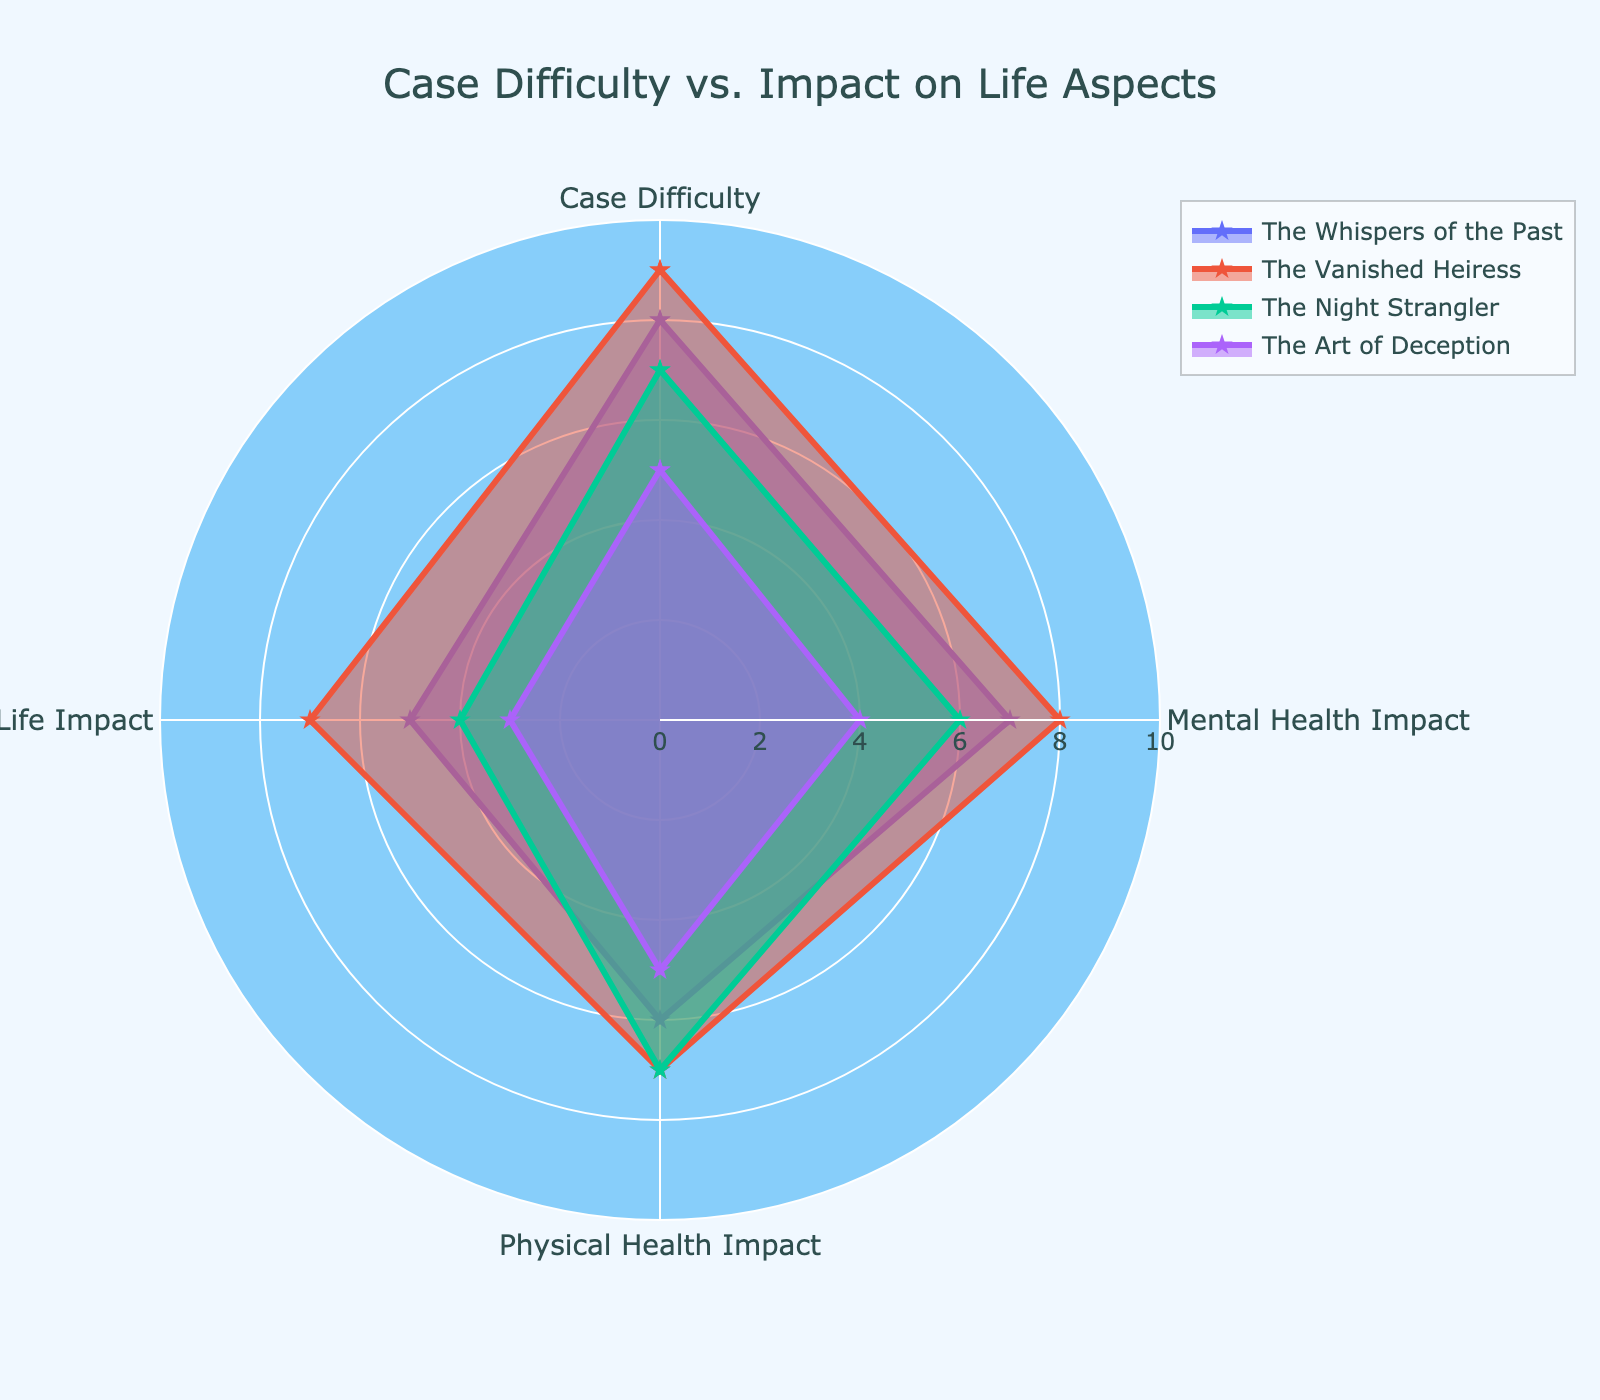What is the title of the radar chart? The title of the radar chart is located at the top of the chart and is clearly labeled.
Answer: Case Difficulty vs. Impact on Life Aspects How many cases are represented in the radar chart? By counting the unique lines or polygons in the radar chart's legend and each category, we can determine the number of cases represented.
Answer: Four Which case has the highest difficulty? Compare the "Case Difficulty" values for each case; the case with the highest value has the highest difficulty.
Answer: The Vanished Heiress Which case has the least impact on social life? Compare the "Social Life Impact" values for each case; the case with the lowest value indicates the least impact on social life.
Answer: The Art of Deception What are the three main categories displayed on the radar chart? The radar chart includes the categories along the axes; the primary three are "Mental Health Impact," "Physical Health Impact," and "Social Life Impact."
Answer: Mental Health Impact, Physical Health Impact, Social Life Impact By how much does the physical health impact of "The Vanished Heiress" surpass that of "The Art of Deception"? Subtract the "Physical Health Impact" value of "The Art of Deception" from that of "The Vanished Heiress."
Answer: 2 Which case shows the highest impact on mental health? Compare the "Mental Health Impact" values across cases; the highest value reveals the case with the highest impact.
Answer: The Vanished Heiress Order the cases based on their social life impact from highest to lowest. List the cases in descending order based on their "Social Life Impact" values.
Answer: The Vanished Heiress, The Whispers of the Past, The Night Strangler, The Art of Deception Which cases have equal physical health impact? Compare the "Physical Health Impact" values; identify the cases with identical values.
Answer: The Vanished Heiress, The Night Strangler 